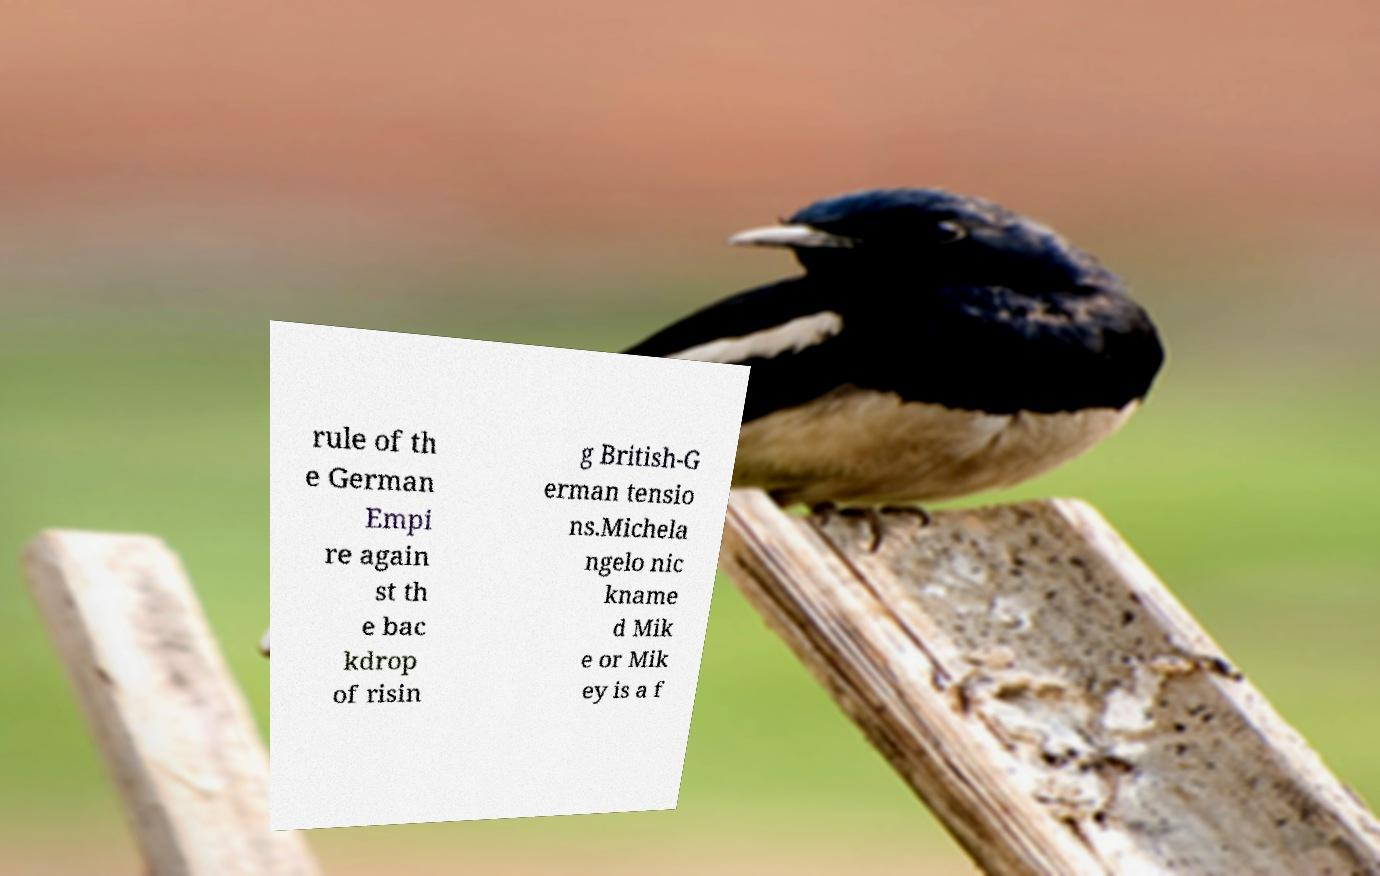Could you assist in decoding the text presented in this image and type it out clearly? rule of th e German Empi re again st th e bac kdrop of risin g British-G erman tensio ns.Michela ngelo nic kname d Mik e or Mik ey is a f 